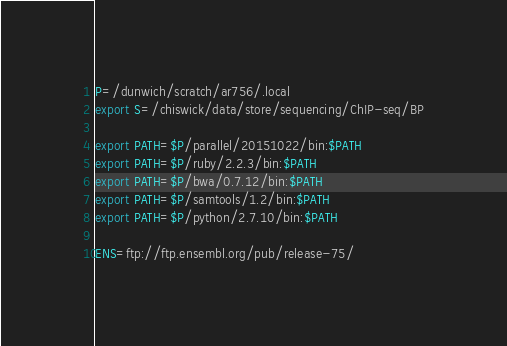<code> <loc_0><loc_0><loc_500><loc_500><_Bash_>P=/dunwich/scratch/ar756/.local
export S=/chiswick/data/store/sequencing/ChIP-seq/BP

export PATH=$P/parallel/20151022/bin:$PATH
export PATH=$P/ruby/2.2.3/bin:$PATH
export PATH=$P/bwa/0.7.12/bin:$PATH
export PATH=$P/samtools/1.2/bin:$PATH
export PATH=$P/python/2.7.10/bin:$PATH

ENS=ftp://ftp.ensembl.org/pub/release-75/</code> 